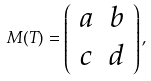<formula> <loc_0><loc_0><loc_500><loc_500>M ( T ) = \left ( \begin{array} { c c } { a } & { b } \\ { c } & { d } \end{array} \right ) ,</formula> 